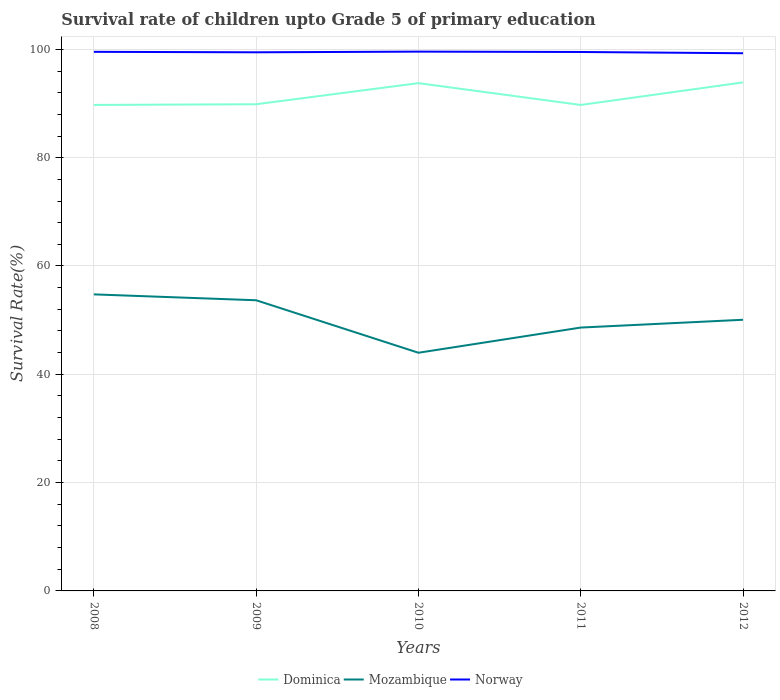How many different coloured lines are there?
Offer a very short reply. 3. Across all years, what is the maximum survival rate of children in Mozambique?
Offer a terse response. 43.98. In which year was the survival rate of children in Dominica maximum?
Offer a very short reply. 2011. What is the total survival rate of children in Mozambique in the graph?
Ensure brevity in your answer.  3.6. What is the difference between the highest and the second highest survival rate of children in Dominica?
Your answer should be compact. 4.16. Is the survival rate of children in Dominica strictly greater than the survival rate of children in Mozambique over the years?
Your answer should be compact. No. How many lines are there?
Your answer should be compact. 3. How many years are there in the graph?
Your answer should be compact. 5. What is the difference between two consecutive major ticks on the Y-axis?
Your answer should be very brief. 20. Are the values on the major ticks of Y-axis written in scientific E-notation?
Your answer should be very brief. No. Does the graph contain any zero values?
Provide a short and direct response. No. Does the graph contain grids?
Provide a short and direct response. Yes. Where does the legend appear in the graph?
Your answer should be compact. Bottom center. How are the legend labels stacked?
Give a very brief answer. Horizontal. What is the title of the graph?
Your answer should be compact. Survival rate of children upto Grade 5 of primary education. What is the label or title of the Y-axis?
Offer a terse response. Survival Rate(%). What is the Survival Rate(%) in Dominica in 2008?
Provide a succinct answer. 89.74. What is the Survival Rate(%) of Mozambique in 2008?
Your answer should be compact. 54.76. What is the Survival Rate(%) in Norway in 2008?
Provide a short and direct response. 99.55. What is the Survival Rate(%) of Dominica in 2009?
Your answer should be very brief. 89.87. What is the Survival Rate(%) in Mozambique in 2009?
Offer a terse response. 53.67. What is the Survival Rate(%) of Norway in 2009?
Your answer should be compact. 99.46. What is the Survival Rate(%) of Dominica in 2010?
Provide a short and direct response. 93.77. What is the Survival Rate(%) of Mozambique in 2010?
Give a very brief answer. 43.98. What is the Survival Rate(%) in Norway in 2010?
Provide a succinct answer. 99.58. What is the Survival Rate(%) of Dominica in 2011?
Keep it short and to the point. 89.74. What is the Survival Rate(%) in Mozambique in 2011?
Offer a terse response. 48.63. What is the Survival Rate(%) in Norway in 2011?
Give a very brief answer. 99.52. What is the Survival Rate(%) of Dominica in 2012?
Ensure brevity in your answer.  93.9. What is the Survival Rate(%) in Mozambique in 2012?
Offer a terse response. 50.07. What is the Survival Rate(%) of Norway in 2012?
Make the answer very short. 99.29. Across all years, what is the maximum Survival Rate(%) of Dominica?
Offer a terse response. 93.9. Across all years, what is the maximum Survival Rate(%) of Mozambique?
Your response must be concise. 54.76. Across all years, what is the maximum Survival Rate(%) of Norway?
Your response must be concise. 99.58. Across all years, what is the minimum Survival Rate(%) in Dominica?
Provide a succinct answer. 89.74. Across all years, what is the minimum Survival Rate(%) in Mozambique?
Your response must be concise. 43.98. Across all years, what is the minimum Survival Rate(%) in Norway?
Your answer should be compact. 99.29. What is the total Survival Rate(%) of Dominica in the graph?
Your answer should be very brief. 457.02. What is the total Survival Rate(%) of Mozambique in the graph?
Your answer should be very brief. 251.12. What is the total Survival Rate(%) of Norway in the graph?
Offer a terse response. 497.4. What is the difference between the Survival Rate(%) of Dominica in 2008 and that in 2009?
Give a very brief answer. -0.12. What is the difference between the Survival Rate(%) in Mozambique in 2008 and that in 2009?
Provide a short and direct response. 1.09. What is the difference between the Survival Rate(%) in Norway in 2008 and that in 2009?
Keep it short and to the point. 0.09. What is the difference between the Survival Rate(%) of Dominica in 2008 and that in 2010?
Keep it short and to the point. -4.02. What is the difference between the Survival Rate(%) of Mozambique in 2008 and that in 2010?
Keep it short and to the point. 10.78. What is the difference between the Survival Rate(%) of Norway in 2008 and that in 2010?
Your answer should be very brief. -0.04. What is the difference between the Survival Rate(%) in Dominica in 2008 and that in 2011?
Your response must be concise. 0. What is the difference between the Survival Rate(%) of Mozambique in 2008 and that in 2011?
Your answer should be compact. 6.13. What is the difference between the Survival Rate(%) in Norway in 2008 and that in 2011?
Provide a succinct answer. 0.03. What is the difference between the Survival Rate(%) of Dominica in 2008 and that in 2012?
Offer a very short reply. -4.16. What is the difference between the Survival Rate(%) in Mozambique in 2008 and that in 2012?
Make the answer very short. 4.69. What is the difference between the Survival Rate(%) in Norway in 2008 and that in 2012?
Make the answer very short. 0.26. What is the difference between the Survival Rate(%) of Dominica in 2009 and that in 2010?
Offer a terse response. -3.9. What is the difference between the Survival Rate(%) of Mozambique in 2009 and that in 2010?
Provide a succinct answer. 9.69. What is the difference between the Survival Rate(%) of Norway in 2009 and that in 2010?
Your response must be concise. -0.12. What is the difference between the Survival Rate(%) in Dominica in 2009 and that in 2011?
Your answer should be compact. 0.13. What is the difference between the Survival Rate(%) of Mozambique in 2009 and that in 2011?
Offer a very short reply. 5.04. What is the difference between the Survival Rate(%) of Norway in 2009 and that in 2011?
Offer a terse response. -0.06. What is the difference between the Survival Rate(%) of Dominica in 2009 and that in 2012?
Offer a terse response. -4.03. What is the difference between the Survival Rate(%) in Mozambique in 2009 and that in 2012?
Your answer should be very brief. 3.6. What is the difference between the Survival Rate(%) of Norway in 2009 and that in 2012?
Offer a terse response. 0.18. What is the difference between the Survival Rate(%) in Dominica in 2010 and that in 2011?
Your answer should be very brief. 4.03. What is the difference between the Survival Rate(%) in Mozambique in 2010 and that in 2011?
Offer a very short reply. -4.65. What is the difference between the Survival Rate(%) of Norway in 2010 and that in 2011?
Give a very brief answer. 0.07. What is the difference between the Survival Rate(%) of Dominica in 2010 and that in 2012?
Offer a terse response. -0.14. What is the difference between the Survival Rate(%) of Mozambique in 2010 and that in 2012?
Give a very brief answer. -6.09. What is the difference between the Survival Rate(%) in Norway in 2010 and that in 2012?
Give a very brief answer. 0.3. What is the difference between the Survival Rate(%) in Dominica in 2011 and that in 2012?
Provide a succinct answer. -4.16. What is the difference between the Survival Rate(%) of Mozambique in 2011 and that in 2012?
Give a very brief answer. -1.44. What is the difference between the Survival Rate(%) in Norway in 2011 and that in 2012?
Your response must be concise. 0.23. What is the difference between the Survival Rate(%) of Dominica in 2008 and the Survival Rate(%) of Mozambique in 2009?
Give a very brief answer. 36.07. What is the difference between the Survival Rate(%) of Dominica in 2008 and the Survival Rate(%) of Norway in 2009?
Your answer should be very brief. -9.72. What is the difference between the Survival Rate(%) of Mozambique in 2008 and the Survival Rate(%) of Norway in 2009?
Give a very brief answer. -44.7. What is the difference between the Survival Rate(%) in Dominica in 2008 and the Survival Rate(%) in Mozambique in 2010?
Provide a short and direct response. 45.76. What is the difference between the Survival Rate(%) in Dominica in 2008 and the Survival Rate(%) in Norway in 2010?
Your answer should be compact. -9.84. What is the difference between the Survival Rate(%) of Mozambique in 2008 and the Survival Rate(%) of Norway in 2010?
Provide a short and direct response. -44.82. What is the difference between the Survival Rate(%) of Dominica in 2008 and the Survival Rate(%) of Mozambique in 2011?
Your answer should be compact. 41.11. What is the difference between the Survival Rate(%) of Dominica in 2008 and the Survival Rate(%) of Norway in 2011?
Make the answer very short. -9.78. What is the difference between the Survival Rate(%) in Mozambique in 2008 and the Survival Rate(%) in Norway in 2011?
Your answer should be very brief. -44.76. What is the difference between the Survival Rate(%) in Dominica in 2008 and the Survival Rate(%) in Mozambique in 2012?
Provide a short and direct response. 39.67. What is the difference between the Survival Rate(%) of Dominica in 2008 and the Survival Rate(%) of Norway in 2012?
Offer a very short reply. -9.54. What is the difference between the Survival Rate(%) in Mozambique in 2008 and the Survival Rate(%) in Norway in 2012?
Your response must be concise. -44.53. What is the difference between the Survival Rate(%) in Dominica in 2009 and the Survival Rate(%) in Mozambique in 2010?
Make the answer very short. 45.89. What is the difference between the Survival Rate(%) in Dominica in 2009 and the Survival Rate(%) in Norway in 2010?
Your answer should be very brief. -9.72. What is the difference between the Survival Rate(%) in Mozambique in 2009 and the Survival Rate(%) in Norway in 2010?
Make the answer very short. -45.91. What is the difference between the Survival Rate(%) in Dominica in 2009 and the Survival Rate(%) in Mozambique in 2011?
Give a very brief answer. 41.24. What is the difference between the Survival Rate(%) in Dominica in 2009 and the Survival Rate(%) in Norway in 2011?
Your answer should be very brief. -9.65. What is the difference between the Survival Rate(%) of Mozambique in 2009 and the Survival Rate(%) of Norway in 2011?
Offer a very short reply. -45.85. What is the difference between the Survival Rate(%) of Dominica in 2009 and the Survival Rate(%) of Mozambique in 2012?
Offer a very short reply. 39.8. What is the difference between the Survival Rate(%) in Dominica in 2009 and the Survival Rate(%) in Norway in 2012?
Provide a short and direct response. -9.42. What is the difference between the Survival Rate(%) in Mozambique in 2009 and the Survival Rate(%) in Norway in 2012?
Offer a terse response. -45.61. What is the difference between the Survival Rate(%) in Dominica in 2010 and the Survival Rate(%) in Mozambique in 2011?
Your answer should be very brief. 45.13. What is the difference between the Survival Rate(%) in Dominica in 2010 and the Survival Rate(%) in Norway in 2011?
Offer a very short reply. -5.75. What is the difference between the Survival Rate(%) of Mozambique in 2010 and the Survival Rate(%) of Norway in 2011?
Your response must be concise. -55.54. What is the difference between the Survival Rate(%) of Dominica in 2010 and the Survival Rate(%) of Mozambique in 2012?
Offer a very short reply. 43.69. What is the difference between the Survival Rate(%) of Dominica in 2010 and the Survival Rate(%) of Norway in 2012?
Offer a very short reply. -5.52. What is the difference between the Survival Rate(%) of Mozambique in 2010 and the Survival Rate(%) of Norway in 2012?
Give a very brief answer. -55.31. What is the difference between the Survival Rate(%) of Dominica in 2011 and the Survival Rate(%) of Mozambique in 2012?
Your answer should be compact. 39.67. What is the difference between the Survival Rate(%) in Dominica in 2011 and the Survival Rate(%) in Norway in 2012?
Your answer should be compact. -9.55. What is the difference between the Survival Rate(%) in Mozambique in 2011 and the Survival Rate(%) in Norway in 2012?
Keep it short and to the point. -50.66. What is the average Survival Rate(%) of Dominica per year?
Give a very brief answer. 91.4. What is the average Survival Rate(%) in Mozambique per year?
Give a very brief answer. 50.22. What is the average Survival Rate(%) in Norway per year?
Your response must be concise. 99.48. In the year 2008, what is the difference between the Survival Rate(%) in Dominica and Survival Rate(%) in Mozambique?
Make the answer very short. 34.98. In the year 2008, what is the difference between the Survival Rate(%) in Dominica and Survival Rate(%) in Norway?
Offer a very short reply. -9.81. In the year 2008, what is the difference between the Survival Rate(%) of Mozambique and Survival Rate(%) of Norway?
Provide a short and direct response. -44.79. In the year 2009, what is the difference between the Survival Rate(%) in Dominica and Survival Rate(%) in Mozambique?
Make the answer very short. 36.19. In the year 2009, what is the difference between the Survival Rate(%) of Dominica and Survival Rate(%) of Norway?
Give a very brief answer. -9.59. In the year 2009, what is the difference between the Survival Rate(%) of Mozambique and Survival Rate(%) of Norway?
Provide a succinct answer. -45.79. In the year 2010, what is the difference between the Survival Rate(%) in Dominica and Survival Rate(%) in Mozambique?
Offer a terse response. 49.78. In the year 2010, what is the difference between the Survival Rate(%) of Dominica and Survival Rate(%) of Norway?
Your response must be concise. -5.82. In the year 2010, what is the difference between the Survival Rate(%) of Mozambique and Survival Rate(%) of Norway?
Offer a very short reply. -55.6. In the year 2011, what is the difference between the Survival Rate(%) of Dominica and Survival Rate(%) of Mozambique?
Make the answer very short. 41.11. In the year 2011, what is the difference between the Survival Rate(%) of Dominica and Survival Rate(%) of Norway?
Ensure brevity in your answer.  -9.78. In the year 2011, what is the difference between the Survival Rate(%) of Mozambique and Survival Rate(%) of Norway?
Your response must be concise. -50.89. In the year 2012, what is the difference between the Survival Rate(%) in Dominica and Survival Rate(%) in Mozambique?
Give a very brief answer. 43.83. In the year 2012, what is the difference between the Survival Rate(%) of Dominica and Survival Rate(%) of Norway?
Keep it short and to the point. -5.38. In the year 2012, what is the difference between the Survival Rate(%) of Mozambique and Survival Rate(%) of Norway?
Keep it short and to the point. -49.21. What is the ratio of the Survival Rate(%) in Dominica in 2008 to that in 2009?
Keep it short and to the point. 1. What is the ratio of the Survival Rate(%) of Mozambique in 2008 to that in 2009?
Provide a succinct answer. 1.02. What is the ratio of the Survival Rate(%) of Norway in 2008 to that in 2009?
Give a very brief answer. 1. What is the ratio of the Survival Rate(%) of Dominica in 2008 to that in 2010?
Make the answer very short. 0.96. What is the ratio of the Survival Rate(%) in Mozambique in 2008 to that in 2010?
Your answer should be compact. 1.25. What is the ratio of the Survival Rate(%) of Norway in 2008 to that in 2010?
Offer a very short reply. 1. What is the ratio of the Survival Rate(%) in Mozambique in 2008 to that in 2011?
Give a very brief answer. 1.13. What is the ratio of the Survival Rate(%) in Dominica in 2008 to that in 2012?
Ensure brevity in your answer.  0.96. What is the ratio of the Survival Rate(%) in Mozambique in 2008 to that in 2012?
Ensure brevity in your answer.  1.09. What is the ratio of the Survival Rate(%) in Norway in 2008 to that in 2012?
Offer a very short reply. 1. What is the ratio of the Survival Rate(%) in Dominica in 2009 to that in 2010?
Make the answer very short. 0.96. What is the ratio of the Survival Rate(%) of Mozambique in 2009 to that in 2010?
Make the answer very short. 1.22. What is the ratio of the Survival Rate(%) of Norway in 2009 to that in 2010?
Your response must be concise. 1. What is the ratio of the Survival Rate(%) of Dominica in 2009 to that in 2011?
Ensure brevity in your answer.  1. What is the ratio of the Survival Rate(%) of Mozambique in 2009 to that in 2011?
Give a very brief answer. 1.1. What is the ratio of the Survival Rate(%) of Dominica in 2009 to that in 2012?
Make the answer very short. 0.96. What is the ratio of the Survival Rate(%) in Mozambique in 2009 to that in 2012?
Your answer should be compact. 1.07. What is the ratio of the Survival Rate(%) of Dominica in 2010 to that in 2011?
Your answer should be very brief. 1.04. What is the ratio of the Survival Rate(%) of Mozambique in 2010 to that in 2011?
Offer a very short reply. 0.9. What is the ratio of the Survival Rate(%) of Dominica in 2010 to that in 2012?
Provide a short and direct response. 1. What is the ratio of the Survival Rate(%) in Mozambique in 2010 to that in 2012?
Give a very brief answer. 0.88. What is the ratio of the Survival Rate(%) in Dominica in 2011 to that in 2012?
Provide a succinct answer. 0.96. What is the ratio of the Survival Rate(%) of Mozambique in 2011 to that in 2012?
Keep it short and to the point. 0.97. What is the difference between the highest and the second highest Survival Rate(%) in Dominica?
Offer a terse response. 0.14. What is the difference between the highest and the second highest Survival Rate(%) in Mozambique?
Keep it short and to the point. 1.09. What is the difference between the highest and the second highest Survival Rate(%) of Norway?
Provide a short and direct response. 0.04. What is the difference between the highest and the lowest Survival Rate(%) of Dominica?
Make the answer very short. 4.16. What is the difference between the highest and the lowest Survival Rate(%) of Mozambique?
Provide a short and direct response. 10.78. What is the difference between the highest and the lowest Survival Rate(%) of Norway?
Provide a short and direct response. 0.3. 